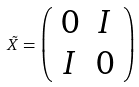<formula> <loc_0><loc_0><loc_500><loc_500>\tilde { X } = \left ( \begin{array} { c c } 0 & I \\ I & 0 \\ \end{array} \right )</formula> 